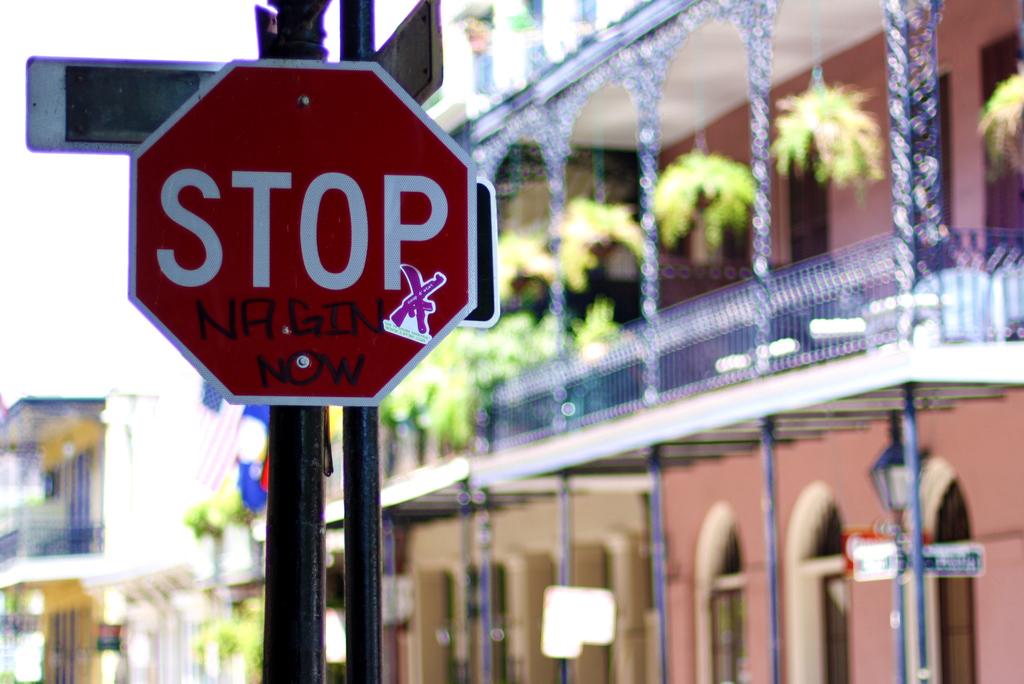What type of sign is the red one?
Offer a very short reply. Stop. What does the graffiti on the sign say?
Your response must be concise. Nagin now. 